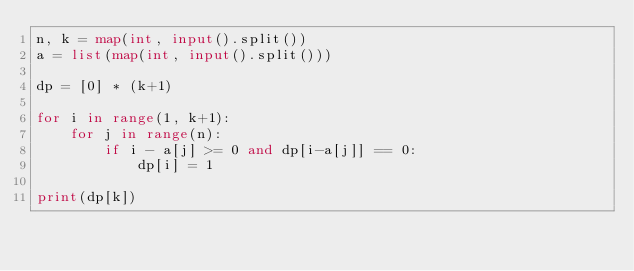Convert code to text. <code><loc_0><loc_0><loc_500><loc_500><_Python_>n, k = map(int, input().split())
a = list(map(int, input().split()))

dp = [0] * (k+1)

for i in range(1, k+1):
    for j in range(n):
        if i - a[j] >= 0 and dp[i-a[j]] == 0:
            dp[i] = 1

print(dp[k])</code> 